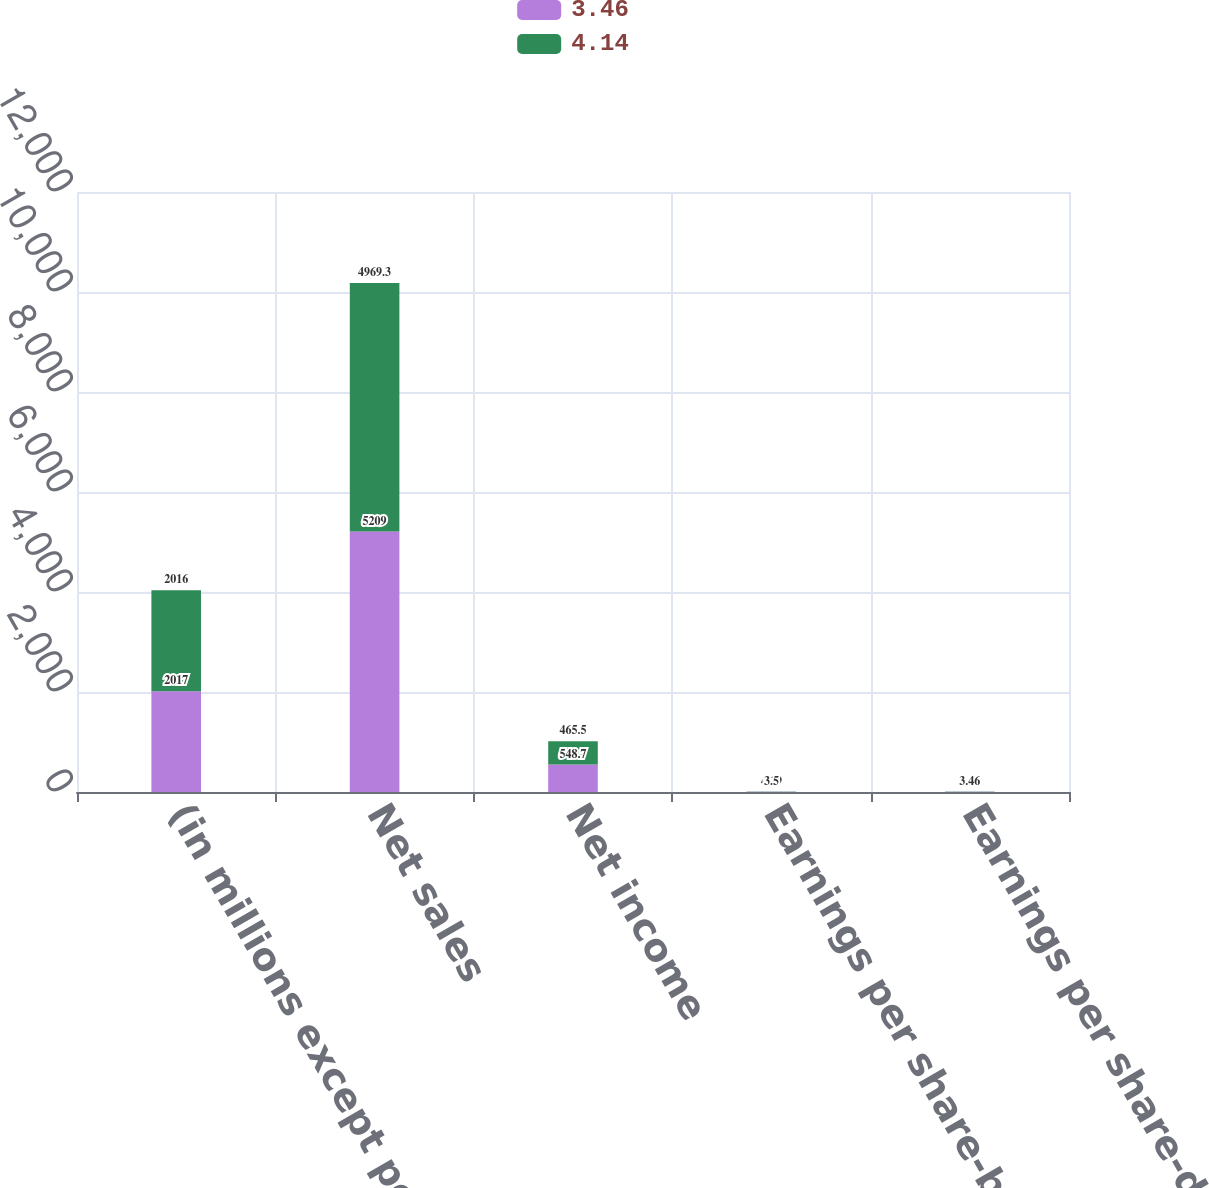Convert chart to OTSL. <chart><loc_0><loc_0><loc_500><loc_500><stacked_bar_chart><ecel><fcel>(in millions except per share<fcel>Net sales<fcel>Net income<fcel>Earnings per share-basic<fcel>Earnings per share-diluted<nl><fcel>3.46<fcel>2017<fcel>5209<fcel>548.7<fcel>4.19<fcel>4.14<nl><fcel>4.14<fcel>2016<fcel>4969.3<fcel>465.5<fcel>3.5<fcel>3.46<nl></chart> 